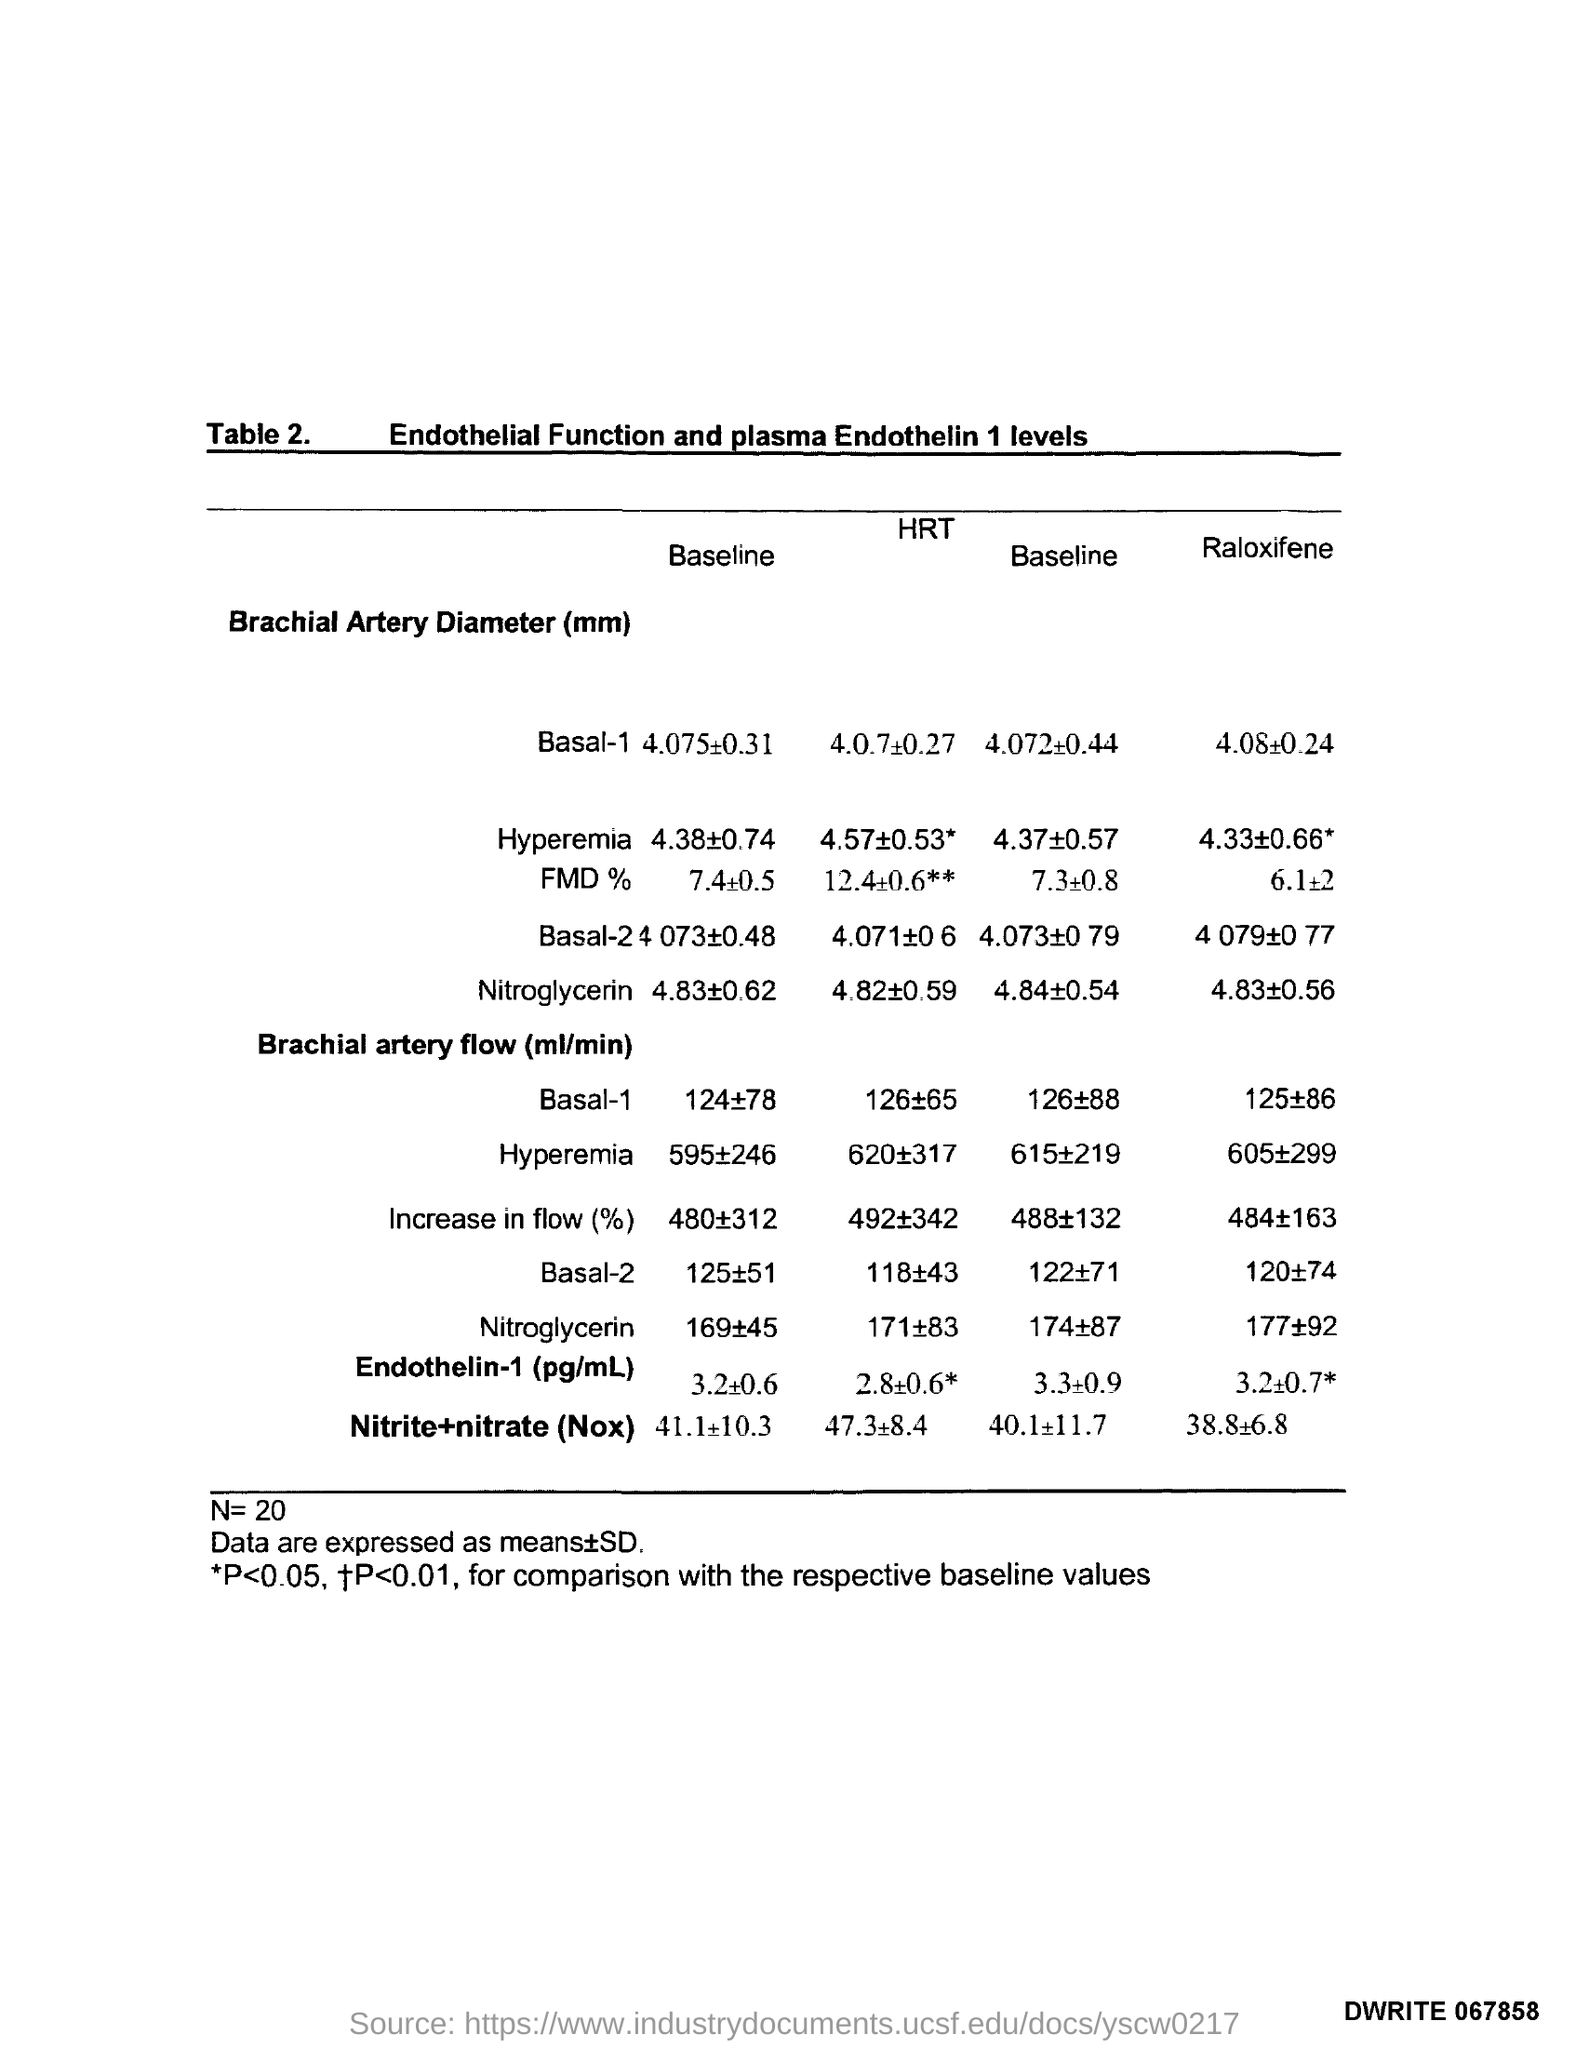What is the value of N?
Ensure brevity in your answer.  20. What is the title of the table?
Keep it short and to the point. Endothelial Function and plasma Endothelin 1 levels. 